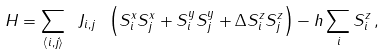<formula> <loc_0><loc_0><loc_500><loc_500>H = \sum _ { \langle i , j \rangle } \ J _ { i , j } \ \left ( S ^ { x } _ { i } S ^ { x } _ { j } + S ^ { y } _ { i } S ^ { y } _ { j } + \Delta S ^ { z } _ { i } S ^ { z } _ { j } \right ) - h \sum _ { i } S ^ { z } _ { i } \, ,</formula> 